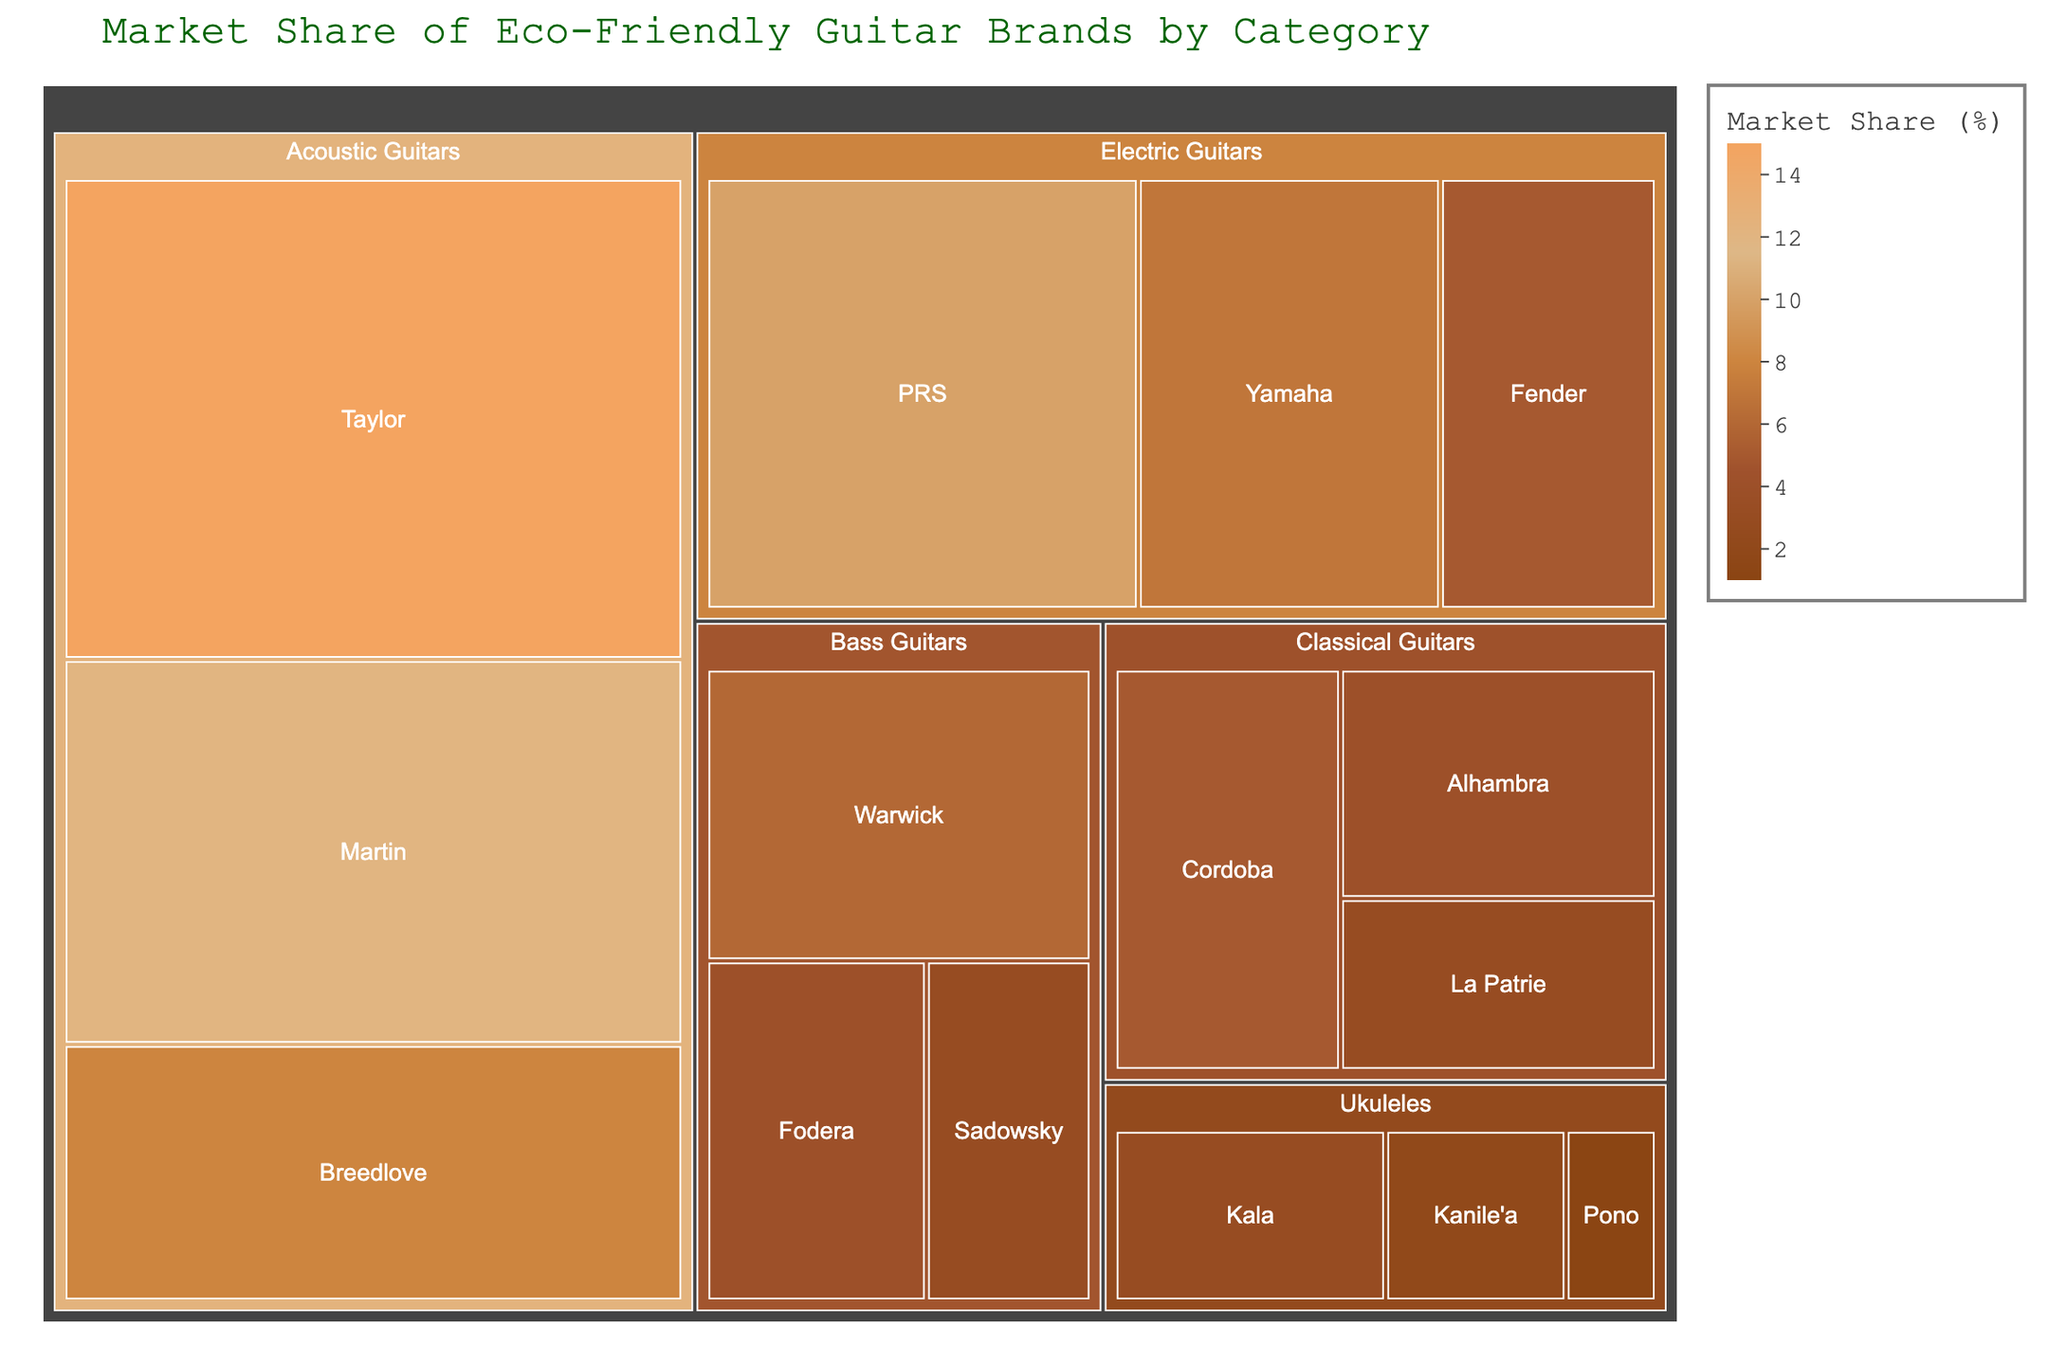What is the title of the Treemap? The title is displayed at the top of the treemap, providing an overview of what the figure represents.
Answer: Market Share of Eco-Friendly Guitar Brands by Category Which brand has the highest market share in Acoustic Guitars? By looking at the Acoustic Guitars category, the brand with the largest area represents the highest market share.
Answer: Taylor What is the combined market share of all Electric Guitar brands? Sum the market shares of PRS, Yamaha, and Fender within the Electric Guitars category (10 + 7 + 5).
Answer: 22% Which category has the smallest total market share, and what is it? Add the market shares of all brands within each category and compare. The smallest total is for Ukuleles (3 + 2 + 1).
Answer: 6% How does the market share of Taylor compare to PRS? Compare the market share values directly: Taylor (15%) and PRS (10%). Taylor has a higher market share.
Answer: Taylor has a higher market share What's the market share of the brand with the second highest share in Classical Guitars? Within the Classical Guitars category, compare the market shares of the brands. Alhambra has the second highest share after Cordoba.
Answer: 4% Which Acoustic Guitar brand has a lower market share than Yamaha in Electric Guitars? Yamaha has a market share of 7% in Electric Guitars. Compare this to the shares of Acoustic Guitar brands, and both Breedlove and Martin have lower shares (8% and 12%).
Answer: Martin What is the average market share for Bass Guitar brands? Add the market share of Warwick (6%), Fodera (4%), and Sadowsky (3%) and divide by 3. (6 + 4 + 3) / 3.
Answer: 4.33% Which two categories have the closest total market shares? Sum the market shares within each category and compare values. The closest are Classical Guitars (5 + 4 + 3 = 12) and Bass Guitars (6 + 4 + 3 = 13).
Answer: Classical and Bass Guitars 